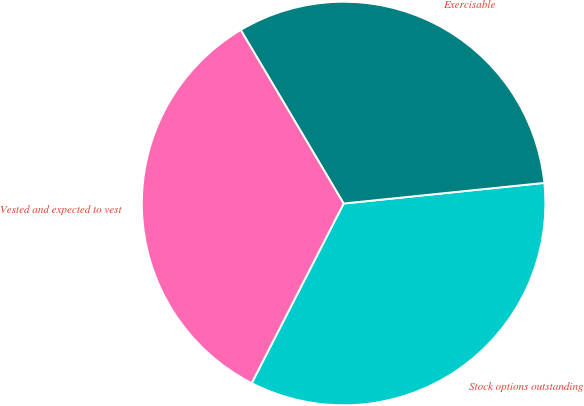Convert chart. <chart><loc_0><loc_0><loc_500><loc_500><pie_chart><fcel>Stock options outstanding<fcel>Exercisable<fcel>Vested and expected to vest<nl><fcel>34.16%<fcel>31.89%<fcel>33.95%<nl></chart> 